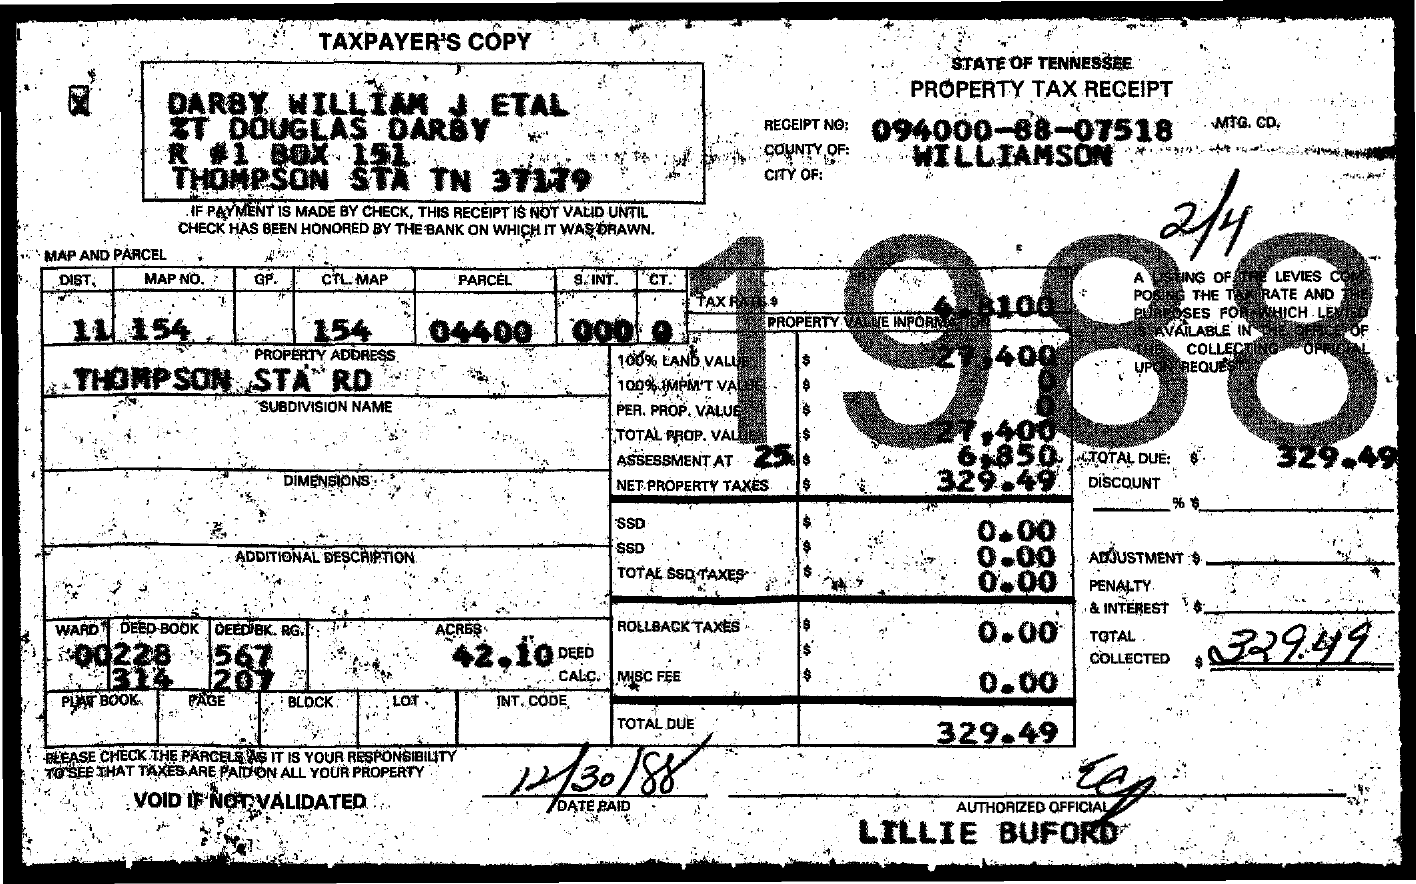Point out several critical features in this image. The total amount of tax collected is 329.49. The receipt number is 094000-88-07518. 